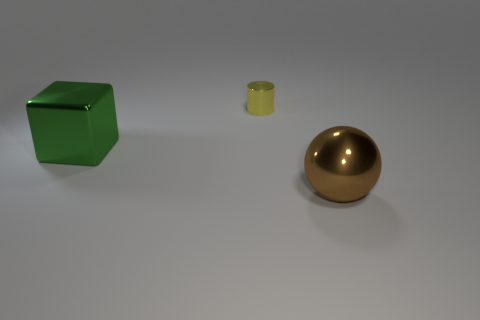Add 2 blocks. How many objects exist? 5 Subtract all cylinders. How many objects are left? 2 Add 1 large green metal blocks. How many large green metal blocks exist? 2 Subtract 0 blue blocks. How many objects are left? 3 Subtract all small metallic things. Subtract all large metallic balls. How many objects are left? 1 Add 2 big green metallic objects. How many big green metallic objects are left? 3 